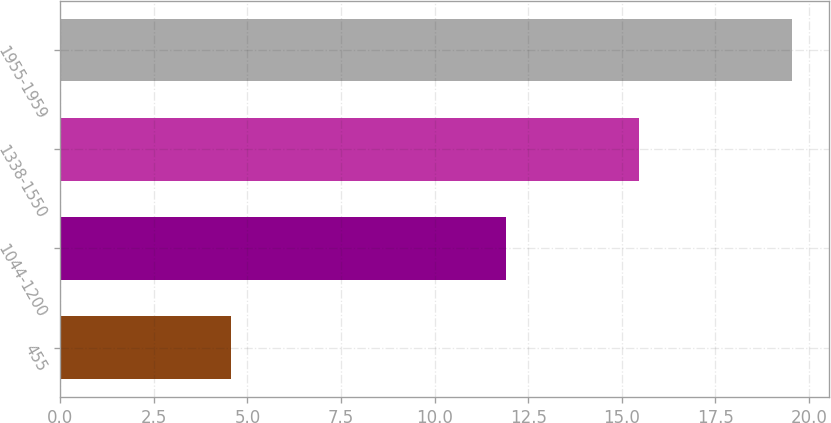<chart> <loc_0><loc_0><loc_500><loc_500><bar_chart><fcel>455<fcel>1044-1200<fcel>1338-1550<fcel>1955-1959<nl><fcel>4.55<fcel>11.9<fcel>15.45<fcel>19.55<nl></chart> 